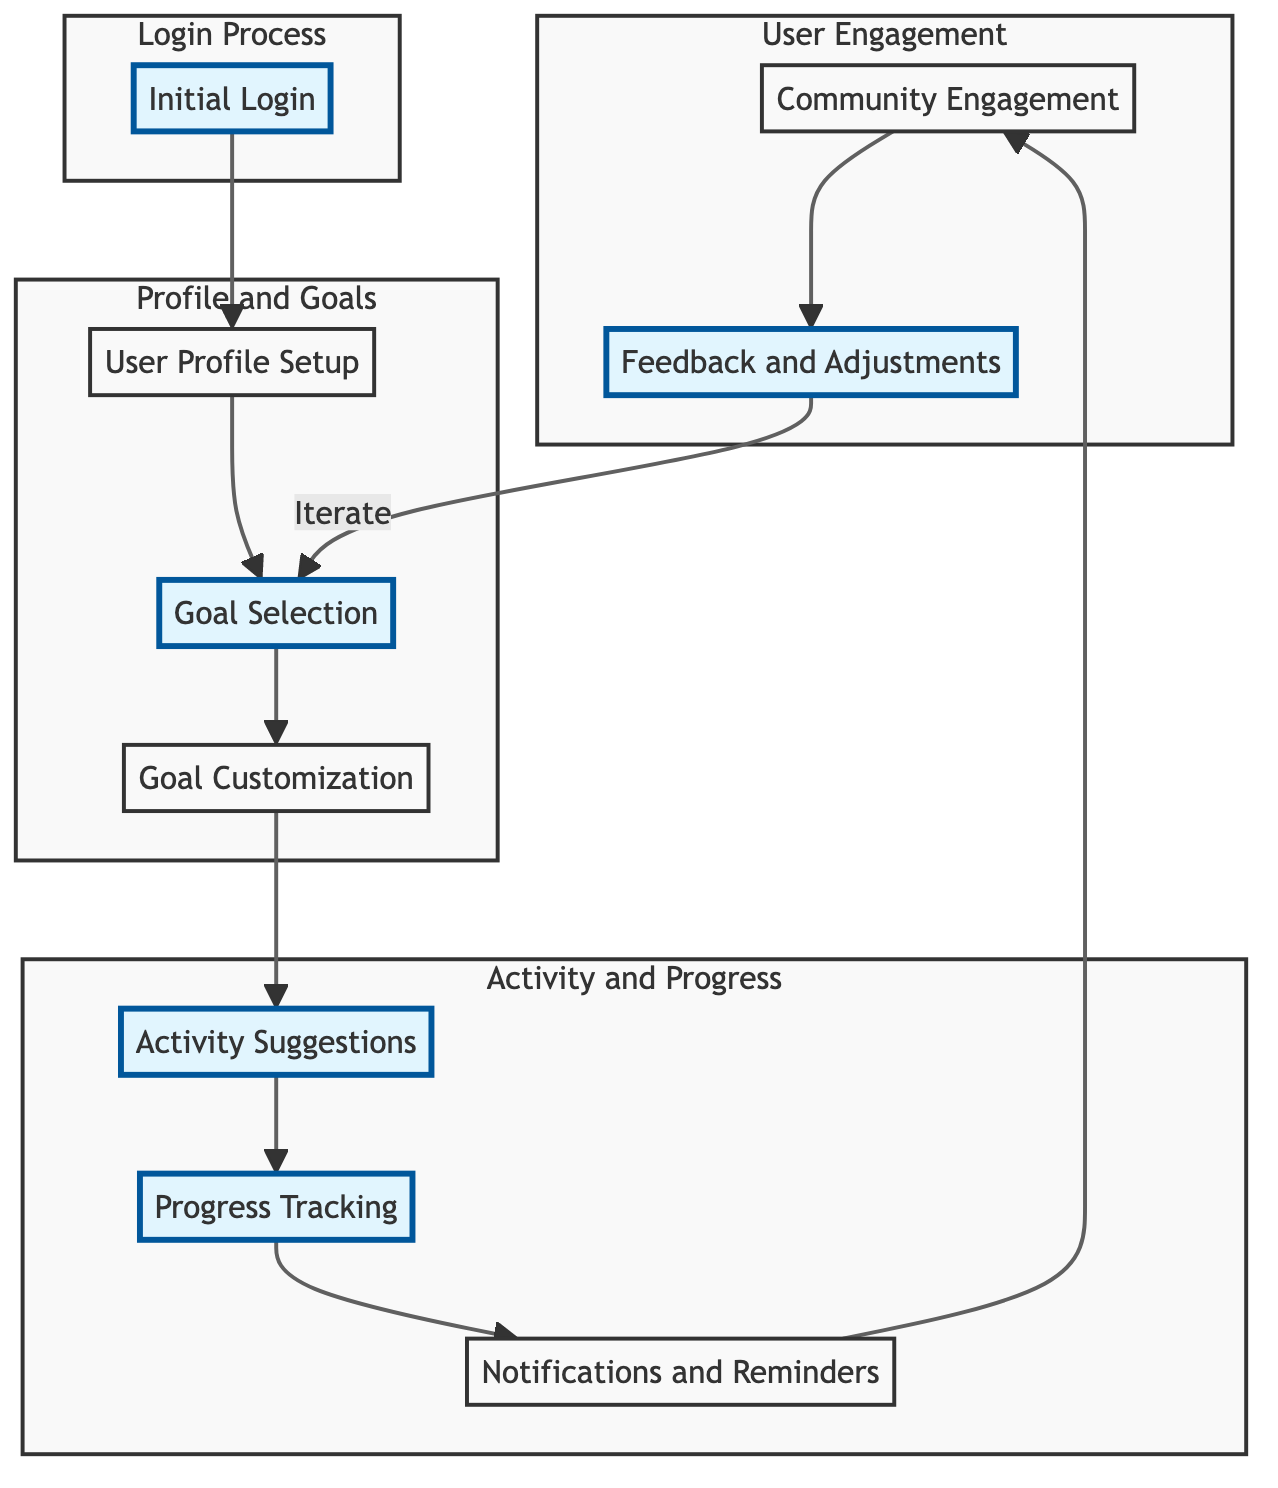What is the first step in the user journey? The diagram indicates that the first step is "Initial Login," which the user must complete before proceeding to the profile setup.
Answer: Initial Login How many stages are in the user journey? By counting the main nodes in the diagram, there are nine stages that the user goes through from login to feedback and adjustments.
Answer: Nine What component is included in the "Goal Customization" stage? The "Goal Customization" stage includes multiple components, one of which is "Target Weight," which the user sets to tailor their fitness goals.
Answer: Target Weight What does the "Community Engagement" stage involve? This stage involves several activities aimed at keeping users motivated and supported through "Discussion Forums" and "Challenge Participation."
Answer: Discussion Forums What action do users take after "Progress Tracking"? After "Progress Tracking," users receive "Notifications and Reminders," which keeps them engaged with the app's features and alerts them about their fitness journey.
Answer: Notifications and Reminders How is the user journey structured in terms of process groups? The diagram depicts the user journey grouped into four main processes: Login, Profile and Goals, Activity and Progress, and User Engagement. This structure helps in identifying the flow of actions within each segment.
Answer: Four main processes What action does the user take if they wish to adjust their goals? Users provide feedback through a "User Feedback Form," which allows them to adjust their fitness goals and make necessary changes to their plans.
Answer: User Feedback Form How many notifications types are presented in the "Notifications and Reminders" stage? The stage includes four types of notifications, including "Workout Reminders" and "Progress Alerts," which are meant to keep users informed and motivated.
Answer: Four types 